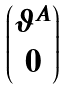<formula> <loc_0><loc_0><loc_500><loc_500>\begin{pmatrix} \vartheta ^ { A } \\ 0 \end{pmatrix}</formula> 